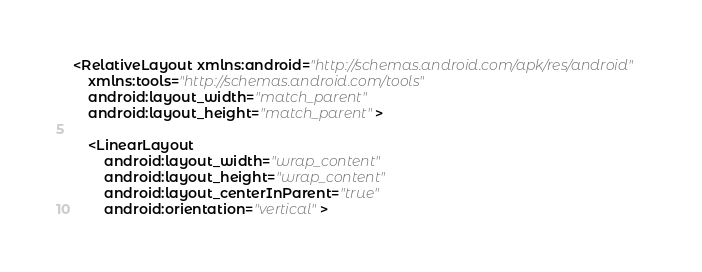<code> <loc_0><loc_0><loc_500><loc_500><_XML_><RelativeLayout xmlns:android="http://schemas.android.com/apk/res/android"
	xmlns:tools="http://schemas.android.com/tools"
	android:layout_width="match_parent"
	android:layout_height="match_parent">

    <LinearLayout
        android:layout_width="wrap_content"
        android:layout_height="wrap_content"
        android:layout_centerInParent="true"
        android:orientation="vertical"></code> 